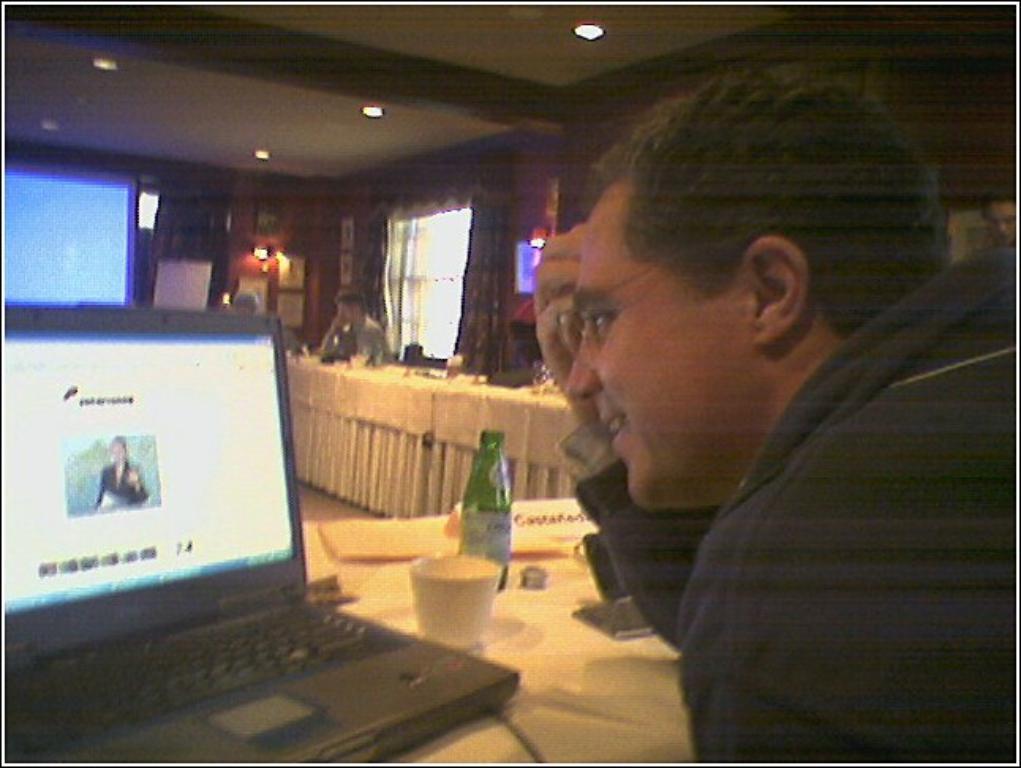Describe this image in one or two sentences. On the right side of the image we can see a man sitting before him there is a table and we can see a laptop, bottle, cup and an object placed on the table. In the background there are people sitting and there is a screen. At the top there are lights and we can see a window. 